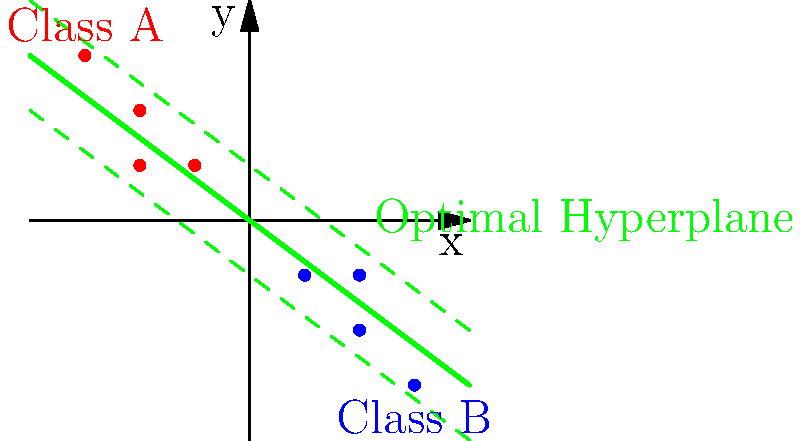Given the 2D feature space shown in the diagram, with red dots representing Class A and blue dots representing Class B, what is the equation of the optimal hyperplane for a linear SVM classifier? Assume the hyperplane passes through the origin. To find the equation of the optimal hyperplane, we need to follow these steps:

1. Observe that the optimal hyperplane passes through the origin (0,0) and is equidistant from the support vectors of both classes.

2. The direction of the hyperplane is perpendicular to the line connecting the centroids of the two classes.

3. From the graph, we can estimate the centroids:
   Class A centroid: $(-2, 1.75)$
   Class B centroid: $(2, -1.75)$

4. The vector connecting the centroids is:
   $\vec{v} = (2 - (-2), -1.75 - 1.75) = (4, -3.5)$

5. The normal vector to the hyperplane should be parallel to this vector. We can simplify it to:
   $\vec{w} = (4, -3.5) \approx (8, -7)$

6. The equation of a hyperplane passing through the origin is of the form:
   $w_1x + w_2y = 0$

7. Substituting our normal vector components:
   $8x - 7y = 0$

8. To simplify, we can divide both sides by 8:
   $x - \frac{7}{8}y = 0$

Therefore, the equation of the optimal hyperplane is $x - \frac{7}{8}y = 0$.
Answer: $x - \frac{7}{8}y = 0$ 